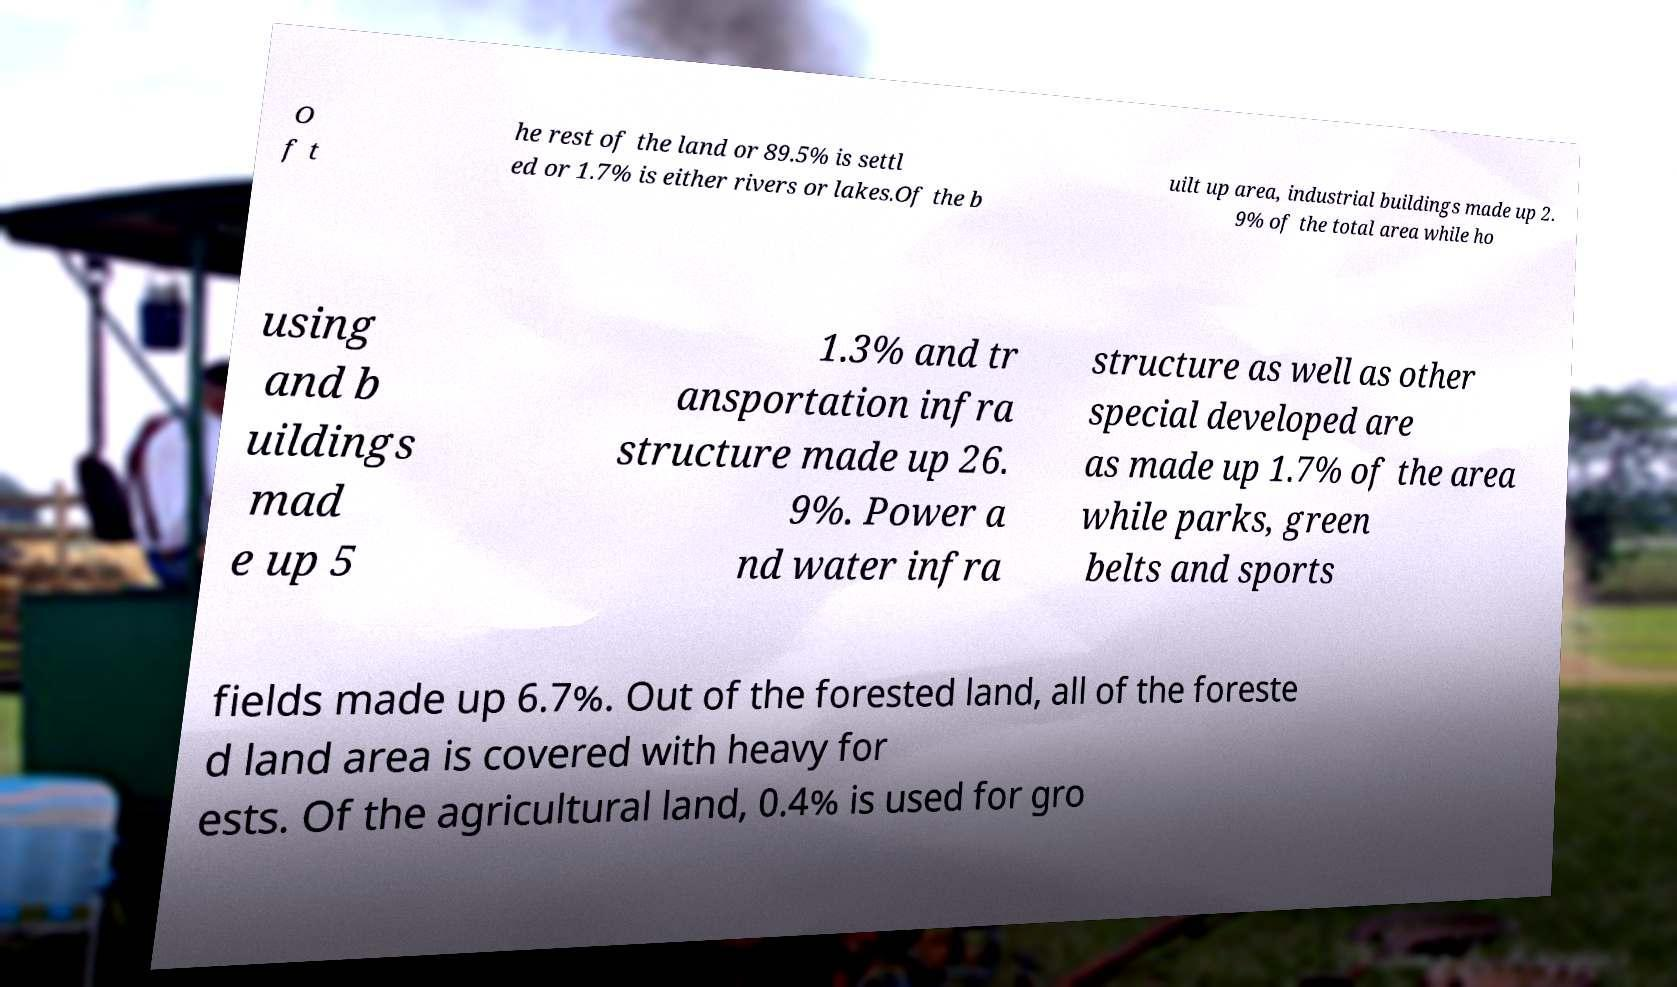Could you extract and type out the text from this image? O f t he rest of the land or 89.5% is settl ed or 1.7% is either rivers or lakes.Of the b uilt up area, industrial buildings made up 2. 9% of the total area while ho using and b uildings mad e up 5 1.3% and tr ansportation infra structure made up 26. 9%. Power a nd water infra structure as well as other special developed are as made up 1.7% of the area while parks, green belts and sports fields made up 6.7%. Out of the forested land, all of the foreste d land area is covered with heavy for ests. Of the agricultural land, 0.4% is used for gro 